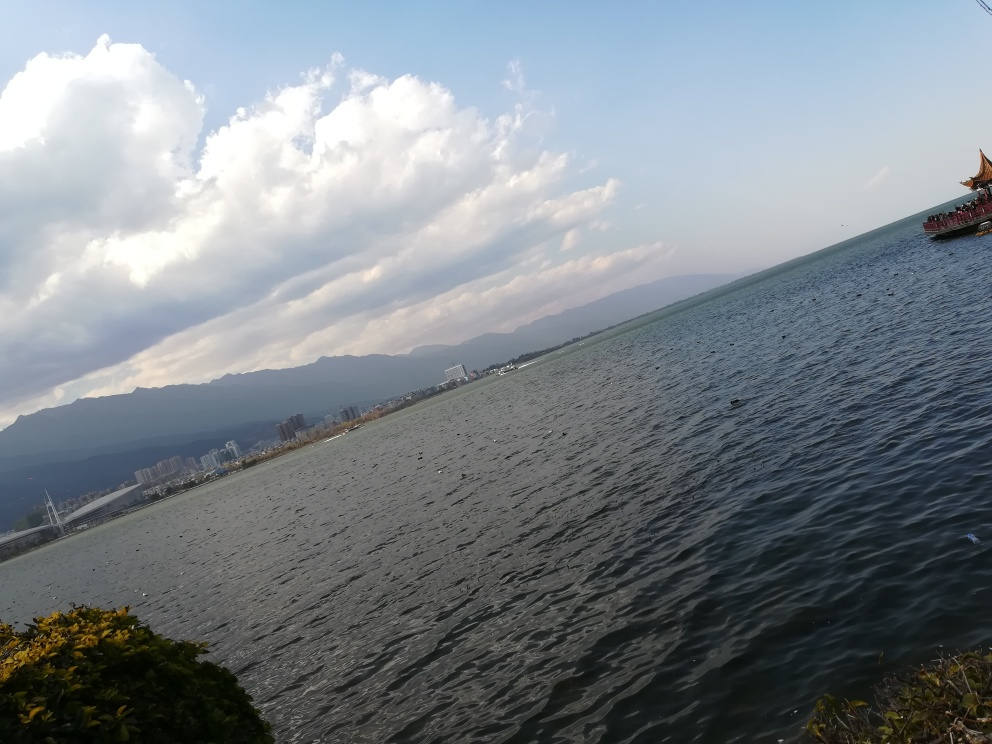Are the texture details of the sea surface rich and clear? The sea surface in the image displays a moderate level of textural detail, with visible ripples and waves that reflect the available light. However, the clarity and resolution of the texture might be affected by the angle of the camera and lighting conditions, making some areas appear less detailed. 